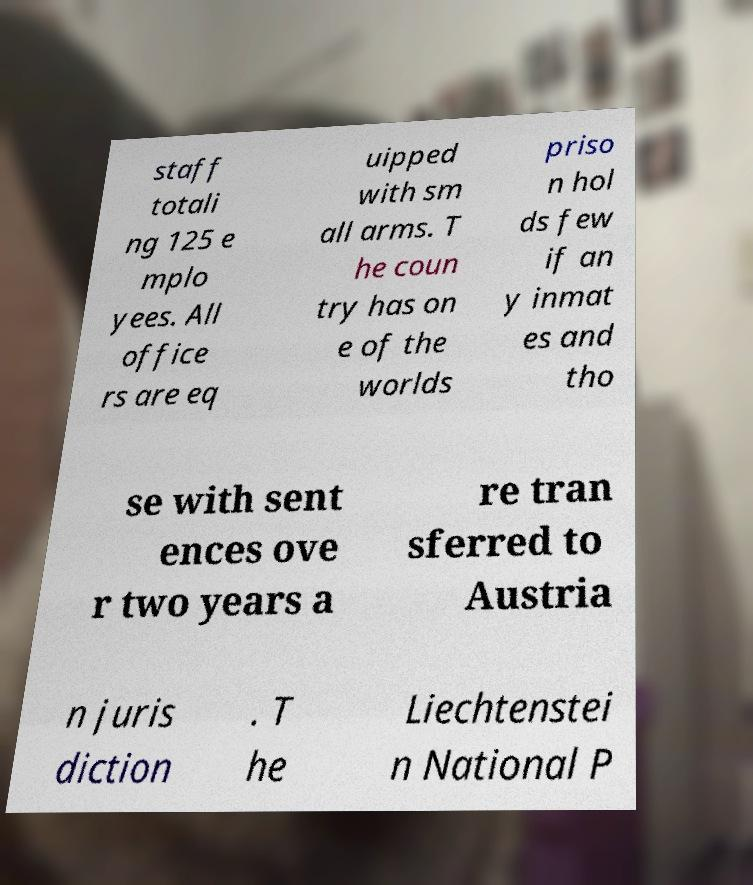For documentation purposes, I need the text within this image transcribed. Could you provide that? staff totali ng 125 e mplo yees. All office rs are eq uipped with sm all arms. T he coun try has on e of the worlds priso n hol ds few if an y inmat es and tho se with sent ences ove r two years a re tran sferred to Austria n juris diction . T he Liechtenstei n National P 